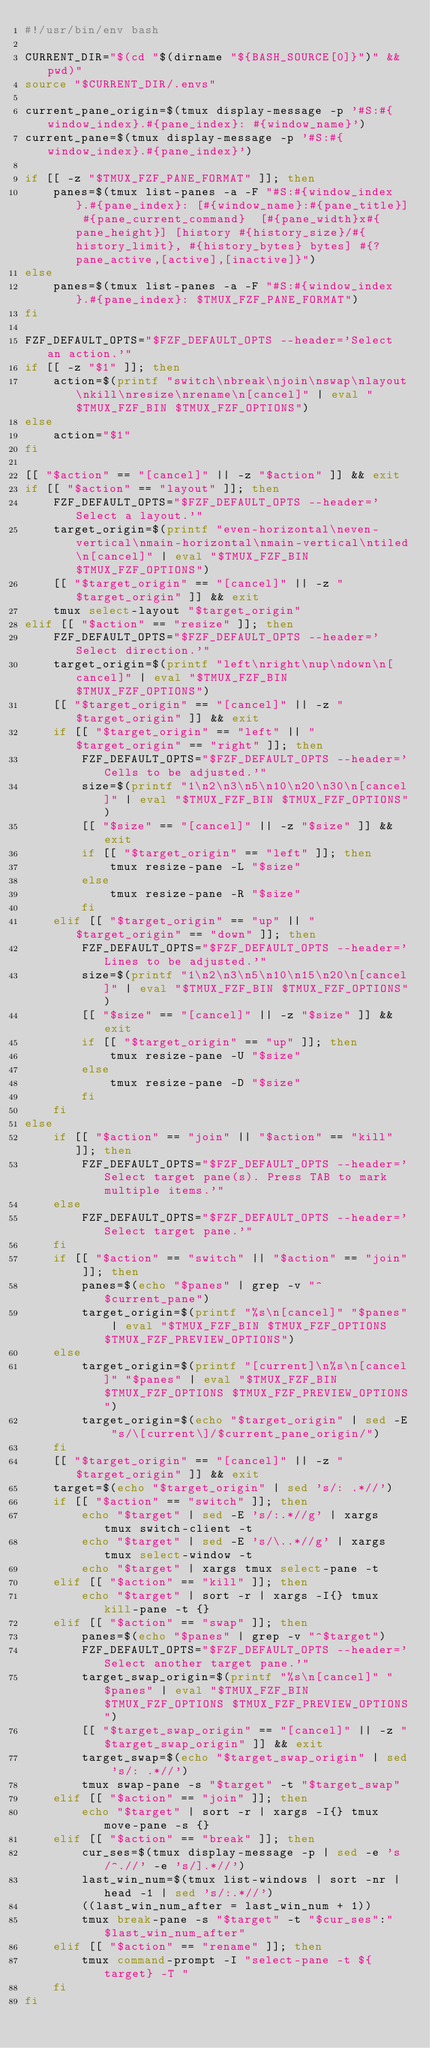<code> <loc_0><loc_0><loc_500><loc_500><_Bash_>#!/usr/bin/env bash

CURRENT_DIR="$(cd "$(dirname "${BASH_SOURCE[0]}")" && pwd)"
source "$CURRENT_DIR/.envs"

current_pane_origin=$(tmux display-message -p '#S:#{window_index}.#{pane_index}: #{window_name}')
current_pane=$(tmux display-message -p '#S:#{window_index}.#{pane_index}')

if [[ -z "$TMUX_FZF_PANE_FORMAT" ]]; then
    panes=$(tmux list-panes -a -F "#S:#{window_index}.#{pane_index}: [#{window_name}:#{pane_title}] #{pane_current_command}  [#{pane_width}x#{pane_height}] [history #{history_size}/#{history_limit}, #{history_bytes} bytes] #{?pane_active,[active],[inactive]}")
else
    panes=$(tmux list-panes -a -F "#S:#{window_index}.#{pane_index}: $TMUX_FZF_PANE_FORMAT")
fi

FZF_DEFAULT_OPTS="$FZF_DEFAULT_OPTS --header='Select an action.'"
if [[ -z "$1" ]]; then
    action=$(printf "switch\nbreak\njoin\nswap\nlayout\nkill\nresize\nrename\n[cancel]" | eval "$TMUX_FZF_BIN $TMUX_FZF_OPTIONS")
else
    action="$1"
fi

[[ "$action" == "[cancel]" || -z "$action" ]] && exit
if [[ "$action" == "layout" ]]; then
    FZF_DEFAULT_OPTS="$FZF_DEFAULT_OPTS --header='Select a layout.'"
    target_origin=$(printf "even-horizontal\neven-vertical\nmain-horizontal\nmain-vertical\ntiled\n[cancel]" | eval "$TMUX_FZF_BIN $TMUX_FZF_OPTIONS")
    [[ "$target_origin" == "[cancel]" || -z "$target_origin" ]] && exit
    tmux select-layout "$target_origin"
elif [[ "$action" == "resize" ]]; then
    FZF_DEFAULT_OPTS="$FZF_DEFAULT_OPTS --header='Select direction.'"
    target_origin=$(printf "left\nright\nup\ndown\n[cancel]" | eval "$TMUX_FZF_BIN $TMUX_FZF_OPTIONS")
    [[ "$target_origin" == "[cancel]" || -z "$target_origin" ]] && exit
    if [[ "$target_origin" == "left" || "$target_origin" == "right" ]]; then
        FZF_DEFAULT_OPTS="$FZF_DEFAULT_OPTS --header='Cells to be adjusted.'"
        size=$(printf "1\n2\n3\n5\n10\n20\n30\n[cancel]" | eval "$TMUX_FZF_BIN $TMUX_FZF_OPTIONS")
        [[ "$size" == "[cancel]" || -z "$size" ]] && exit
        if [[ "$target_origin" == "left" ]]; then
            tmux resize-pane -L "$size"
        else
            tmux resize-pane -R "$size"
        fi
    elif [[ "$target_origin" == "up" || "$target_origin" == "down" ]]; then
        FZF_DEFAULT_OPTS="$FZF_DEFAULT_OPTS --header='Lines to be adjusted.'"
        size=$(printf "1\n2\n3\n5\n10\n15\n20\n[cancel]" | eval "$TMUX_FZF_BIN $TMUX_FZF_OPTIONS")
        [[ "$size" == "[cancel]" || -z "$size" ]] && exit
        if [[ "$target_origin" == "up" ]]; then
            tmux resize-pane -U "$size"
        else
            tmux resize-pane -D "$size"
        fi
    fi
else
    if [[ "$action" == "join" || "$action" == "kill" ]]; then
        FZF_DEFAULT_OPTS="$FZF_DEFAULT_OPTS --header='Select target pane(s). Press TAB to mark multiple items.'"
    else
        FZF_DEFAULT_OPTS="$FZF_DEFAULT_OPTS --header='Select target pane.'"
    fi
    if [[ "$action" == "switch" || "$action" == "join" ]]; then
        panes=$(echo "$panes" | grep -v "^$current_pane")
        target_origin=$(printf "%s\n[cancel]" "$panes" | eval "$TMUX_FZF_BIN $TMUX_FZF_OPTIONS $TMUX_FZF_PREVIEW_OPTIONS")
    else
        target_origin=$(printf "[current]\n%s\n[cancel]" "$panes" | eval "$TMUX_FZF_BIN $TMUX_FZF_OPTIONS $TMUX_FZF_PREVIEW_OPTIONS")
        target_origin=$(echo "$target_origin" | sed -E "s/\[current\]/$current_pane_origin/")
    fi
    [[ "$target_origin" == "[cancel]" || -z "$target_origin" ]] && exit
    target=$(echo "$target_origin" | sed 's/: .*//')
    if [[ "$action" == "switch" ]]; then
        echo "$target" | sed -E 's/:.*//g' | xargs tmux switch-client -t
        echo "$target" | sed -E 's/\..*//g' | xargs tmux select-window -t
        echo "$target" | xargs tmux select-pane -t
    elif [[ "$action" == "kill" ]]; then
        echo "$target" | sort -r | xargs -I{} tmux kill-pane -t {}
    elif [[ "$action" == "swap" ]]; then
        panes=$(echo "$panes" | grep -v "^$target")
        FZF_DEFAULT_OPTS="$FZF_DEFAULT_OPTS --header='Select another target pane.'"
        target_swap_origin=$(printf "%s\n[cancel]" "$panes" | eval "$TMUX_FZF_BIN $TMUX_FZF_OPTIONS $TMUX_FZF_PREVIEW_OPTIONS")
        [[ "$target_swap_origin" == "[cancel]" || -z "$target_swap_origin" ]] && exit
        target_swap=$(echo "$target_swap_origin" | sed 's/: .*//')
        tmux swap-pane -s "$target" -t "$target_swap"
    elif [[ "$action" == "join" ]]; then
        echo "$target" | sort -r | xargs -I{} tmux move-pane -s {}
    elif [[ "$action" == "break" ]]; then
        cur_ses=$(tmux display-message -p | sed -e 's/^.//' -e 's/].*//')
        last_win_num=$(tmux list-windows | sort -nr | head -1 | sed 's/:.*//')
        ((last_win_num_after = last_win_num + 1))
        tmux break-pane -s "$target" -t "$cur_ses":"$last_win_num_after"
    elif [[ "$action" == "rename" ]]; then
        tmux command-prompt -I "select-pane -t ${target} -T "
    fi
fi
</code> 